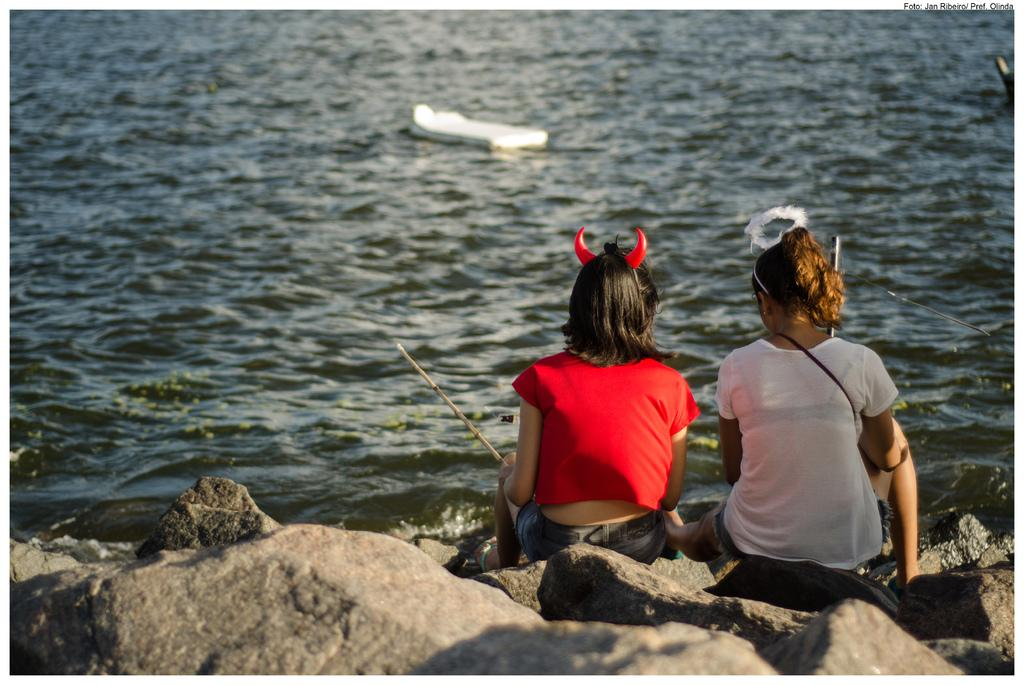How many people are in the image? There are two people in the image. What are the people doing in the image? The people are sitting on rocks. What is in front of the people? There is a river in front of the people. What type of clothing are the people wearing? The people are wearing t-shirts. What type of door can be seen in the image? There is no door present in the image. Are there any cacti visible in the image? There are no cacti visible in the image. 